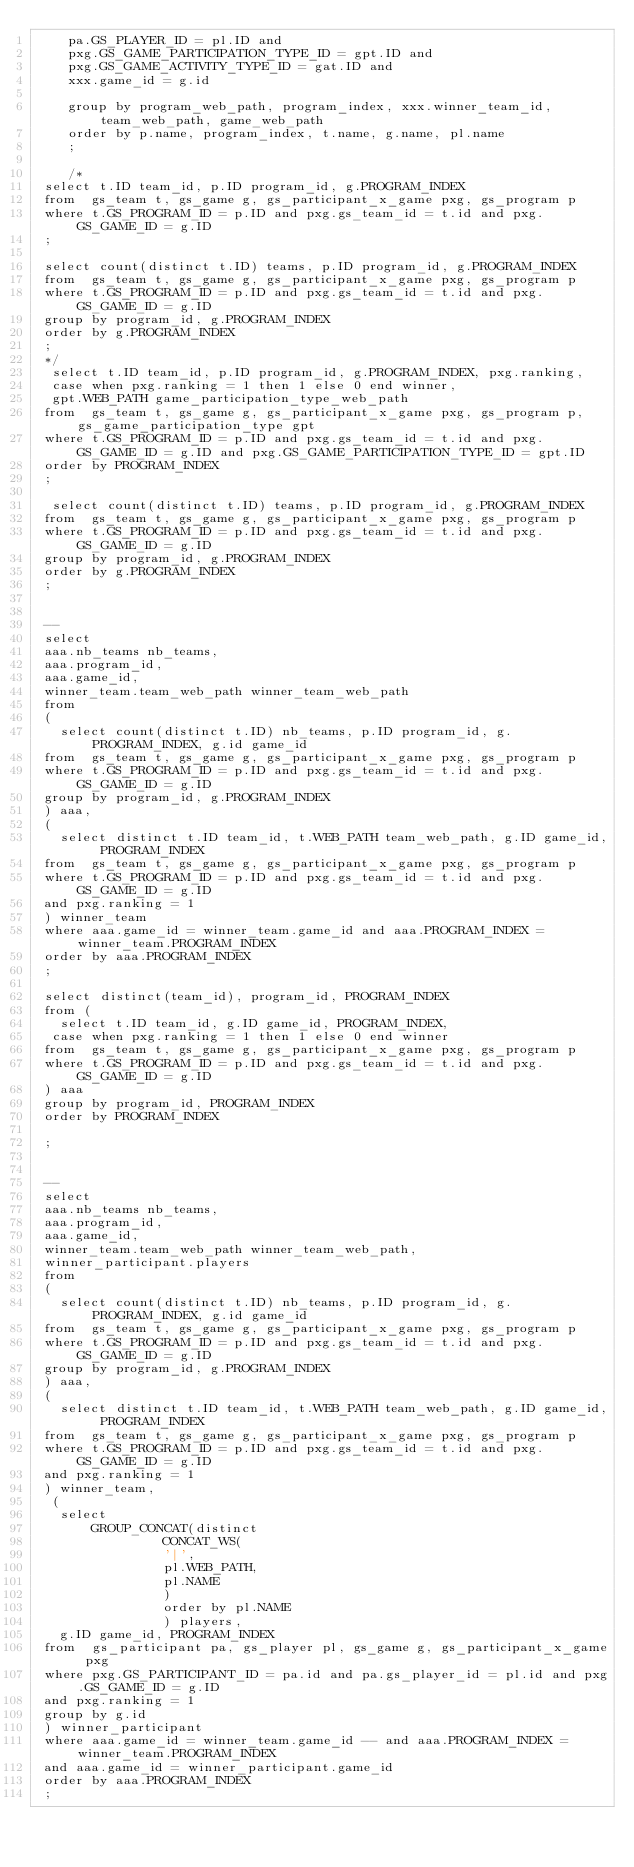Convert code to text. <code><loc_0><loc_0><loc_500><loc_500><_SQL_>	pa.GS_PLAYER_ID = pl.ID and
    pxg.GS_GAME_PARTICIPATION_TYPE_ID = gpt.ID and
    pxg.GS_GAME_ACTIVITY_TYPE_ID = gat.ID and 
    xxx.game_id = g.id
    
    group by program_web_path, program_index, xxx.winner_team_id, team_web_path, game_web_path
    order by p.name, program_index, t.name, g.name, pl.name
    ;
    
    /* 
 select t.ID team_id, p.ID program_id, g.PROGRAM_INDEX
 from  gs_team t, gs_game g, gs_participant_x_game pxg, gs_program p
 where t.GS_PROGRAM_ID = p.ID and pxg.gs_team_id = t.id and pxg.GS_GAME_ID = g.ID
 ;

 select count(distinct t.ID) teams, p.ID program_id, g.PROGRAM_INDEX
 from  gs_team t, gs_game g, gs_participant_x_game pxg, gs_program p
 where t.GS_PROGRAM_ID = p.ID and pxg.gs_team_id = t.id and pxg.GS_GAME_ID = g.ID
 group by program_id, g.PROGRAM_INDEX
 order by g.PROGRAM_INDEX
 ;
 */
  select t.ID team_id, p.ID program_id, g.PROGRAM_INDEX, pxg.ranking,
  case when pxg.ranking = 1 then 1 else 0 end winner,
  gpt.WEB_PATH game_participation_type_web_path
 from  gs_team t, gs_game g, gs_participant_x_game pxg, gs_program p, gs_game_participation_type gpt
 where t.GS_PROGRAM_ID = p.ID and pxg.gs_team_id = t.id and pxg.GS_GAME_ID = g.ID and pxg.GS_GAME_PARTICIPATION_TYPE_ID = gpt.ID
 order by PROGRAM_INDEX
 ;
 
  select count(distinct t.ID) teams, p.ID program_id, g.PROGRAM_INDEX
 from  gs_team t, gs_game g, gs_participant_x_game pxg, gs_program p
 where t.GS_PROGRAM_ID = p.ID and pxg.gs_team_id = t.id and pxg.GS_GAME_ID = g.ID
 group by program_id, g.PROGRAM_INDEX
 order by g.PROGRAM_INDEX
 ;
 
 
 --
 select 
 aaa.nb_teams nb_teams,
 aaa.program_id,
 aaa.game_id,
 winner_team.team_web_path winner_team_web_path 
 from 
 (
   select count(distinct t.ID) nb_teams, p.ID program_id, g.PROGRAM_INDEX, g.id game_id
 from  gs_team t, gs_game g, gs_participant_x_game pxg, gs_program p
 where t.GS_PROGRAM_ID = p.ID and pxg.gs_team_id = t.id and pxg.GS_GAME_ID = g.ID
 group by program_id, g.PROGRAM_INDEX
 ) aaa,
 (
   select distinct t.ID team_id, t.WEB_PATH team_web_path, g.ID game_id, PROGRAM_INDEX
 from  gs_team t, gs_game g, gs_participant_x_game pxg, gs_program p
 where t.GS_PROGRAM_ID = p.ID and pxg.gs_team_id = t.id and pxg.GS_GAME_ID = g.ID
 and pxg.ranking = 1
 ) winner_team
 where aaa.game_id = winner_team.game_id and aaa.PROGRAM_INDEX = winner_team.PROGRAM_INDEX
 order by aaa.PROGRAM_INDEX
 ;
 
 select distinct(team_id), program_id, PROGRAM_INDEX
 from (
   select t.ID team_id, g.ID game_id, PROGRAM_INDEX,
  case when pxg.ranking = 1 then 1 else 0 end winner
 from  gs_team t, gs_game g, gs_participant_x_game pxg, gs_program p
 where t.GS_PROGRAM_ID = p.ID and pxg.gs_team_id = t.id and pxg.GS_GAME_ID = g.ID
 ) aaa
 group by program_id, PROGRAM_INDEX
 order by PROGRAM_INDEX
 
 ;
 
  
 --
 select 
 aaa.nb_teams nb_teams,
 aaa.program_id,
 aaa.game_id,
 winner_team.team_web_path winner_team_web_path,
 winner_participant.players
 from 
 (
   select count(distinct t.ID) nb_teams, p.ID program_id, g.PROGRAM_INDEX, g.id game_id
 from  gs_team t, gs_game g, gs_participant_x_game pxg, gs_program p
 where t.GS_PROGRAM_ID = p.ID and pxg.gs_team_id = t.id and pxg.GS_GAME_ID = g.ID
 group by program_id, g.PROGRAM_INDEX
 ) aaa,
 (
   select distinct t.ID team_id, t.WEB_PATH team_web_path, g.ID game_id, PROGRAM_INDEX
 from  gs_team t, gs_game g, gs_participant_x_game pxg, gs_program p
 where t.GS_PROGRAM_ID = p.ID and pxg.gs_team_id = t.id and pxg.GS_GAME_ID = g.ID
 and pxg.ranking = 1
 ) winner_team,
  (
   select 
       GROUP_CONCAT(distinct
				CONCAT_WS(
				'|',
				pl.WEB_PATH,
                pl.NAME
				)
				order by pl.NAME
				) players,
   g.ID game_id, PROGRAM_INDEX
 from  gs_participant pa, gs_player pl, gs_game g, gs_participant_x_game pxg
 where pxg.GS_PARTICIPANT_ID = pa.id and pa.gs_player_id = pl.id and pxg.GS_GAME_ID = g.ID
 and pxg.ranking = 1
 group by g.id
 ) winner_participant
 where aaa.game_id = winner_team.game_id -- and aaa.PROGRAM_INDEX = winner_team.PROGRAM_INDEX
 and aaa.game_id = winner_participant.game_id
 order by aaa.PROGRAM_INDEX
 ;</code> 